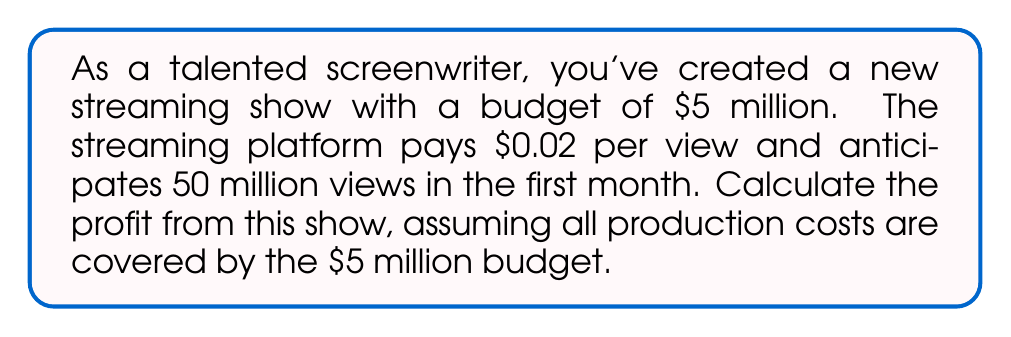Help me with this question. Let's break this down step-by-step:

1) First, we need to calculate the revenue generated from views:
   Revenue = (Number of views) × (Payment per view)
   $$ \text{Revenue} = 50,000,000 \times \$0.02 = \$1,000,000 $$

2) Now, we know the production costs:
   $$ \text{Production Costs} = \$5,000,000 $$

3) To calculate profit, we use the formula:
   $$ \text{Profit} = \text{Revenue} - \text{Costs} $$

4) Plugging in our values:
   $$ \text{Profit} = \$1,000,000 - \$5,000,000 = -\$4,000,000 $$

The negative result indicates a loss rather than a profit.
Answer: $-\$4,000,000$ 